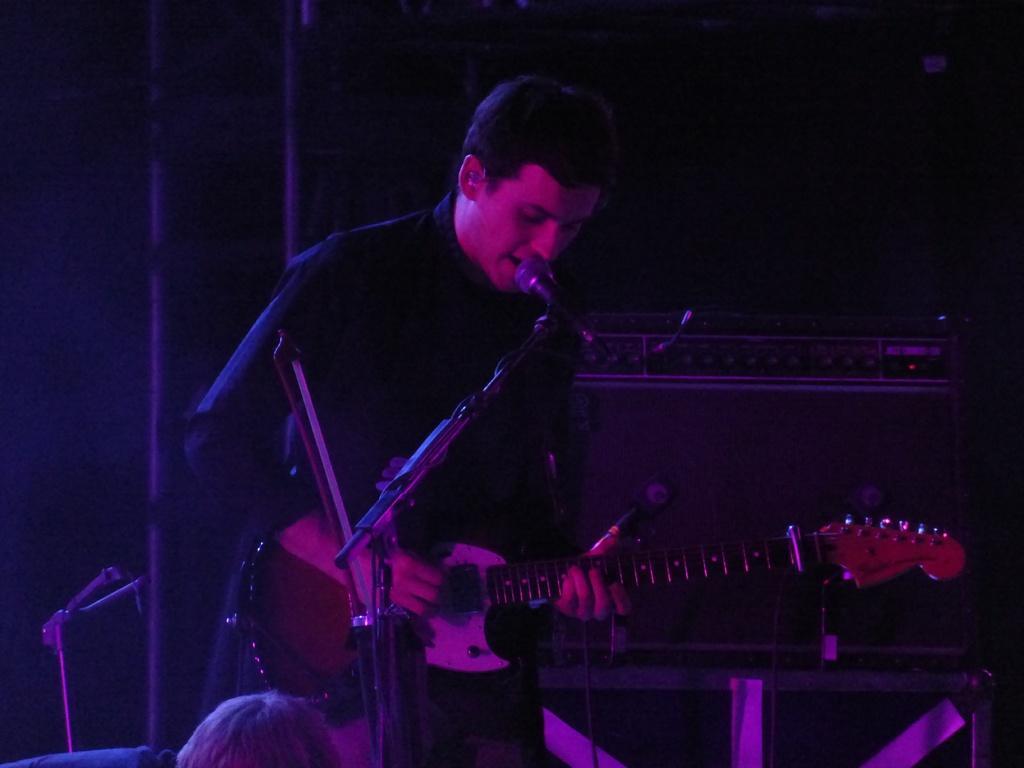Describe this image in one or two sentences. This man is playing a guitar and singing in-front of a mic. This is mic with holder. 